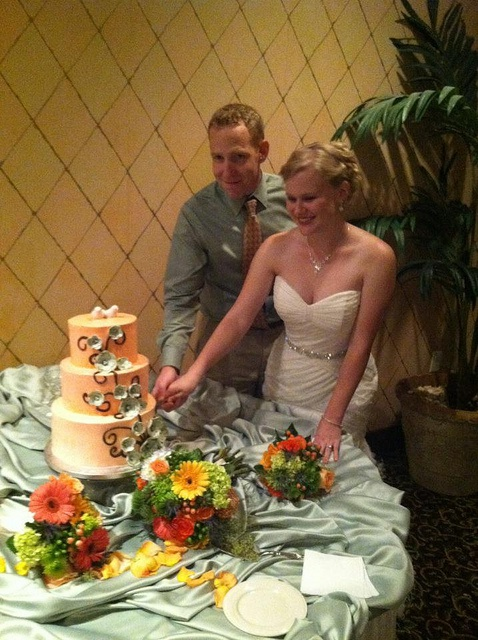Describe the objects in this image and their specific colors. I can see dining table in olive, beige, darkgray, and darkgreen tones, potted plant in olive and black tones, potted plant in olive and black tones, people in olive, brown, maroon, and tan tones, and people in olive, maroon, black, and gray tones in this image. 